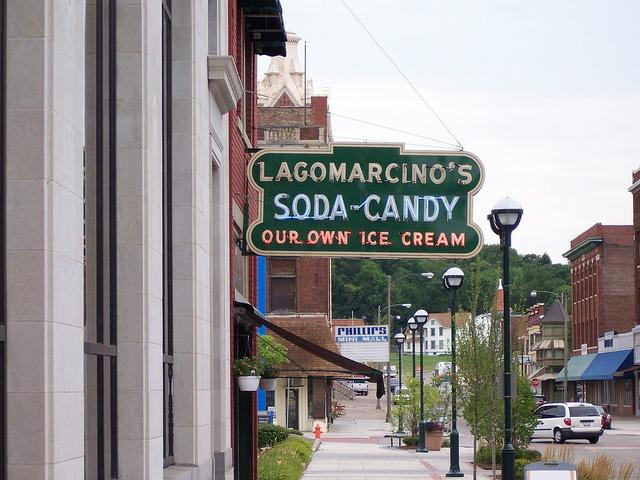What product is made at and for Lagomarcino's? Please explain your reasoning. ice cream. The sign clearly states the product. these types of signs are common on store fronts. 